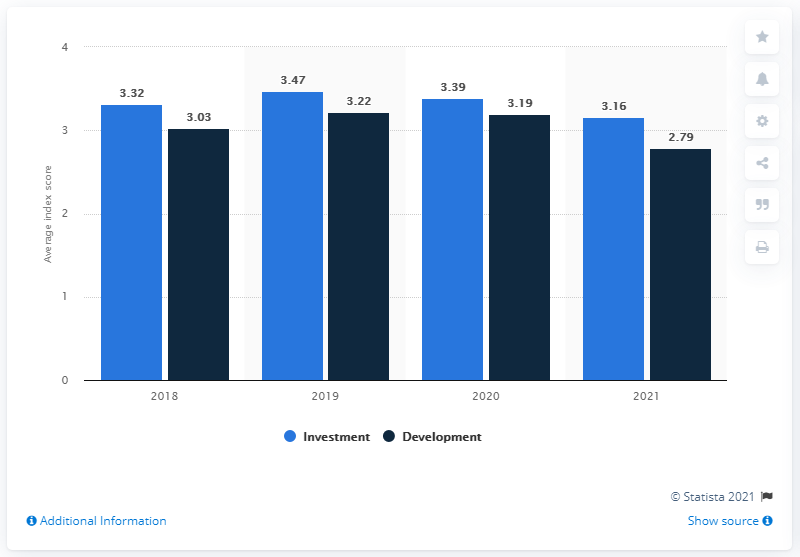List a handful of essential elements in this visual. The outlook for investment in business parks in 2021 is expected to be favorable, with a forecasted value of 3.16. Determine the missing value in the series of numbers, 3.32, 3.03, 3.47, 3.22, 3.39, 3.16, 2.79, by finding the value between 3.19 and 3.19. The ratio between development and investment in 2021 was 1.132616487... 